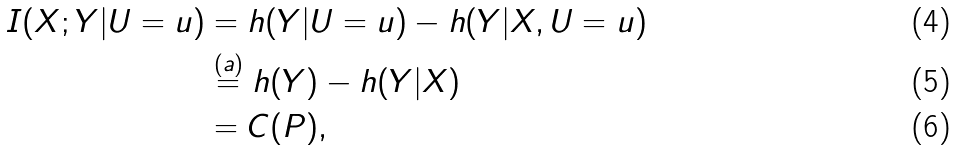Convert formula to latex. <formula><loc_0><loc_0><loc_500><loc_500>I ( X ; Y | U = u ) & = h ( Y | U = u ) - h ( Y | X , U = u ) \\ & \stackrel { ( a ) } { = } h ( Y ) - h ( Y | X ) \\ & = C ( P ) ,</formula> 